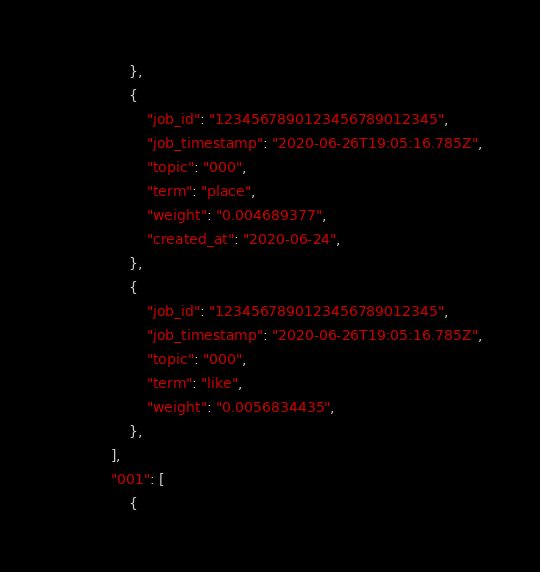<code> <loc_0><loc_0><loc_500><loc_500><_Python_>                },
                {
                    "job_id": "1234567890123456789012345",
                    "job_timestamp": "2020-06-26T19:05:16.785Z",
                    "topic": "000",
                    "term": "place",
                    "weight": "0.004689377",
                    "created_at": "2020-06-24",
                },
                {
                    "job_id": "1234567890123456789012345",
                    "job_timestamp": "2020-06-26T19:05:16.785Z",
                    "topic": "000",
                    "term": "like",
                    "weight": "0.0056834435",
                },
            ],
            "001": [
                {</code> 